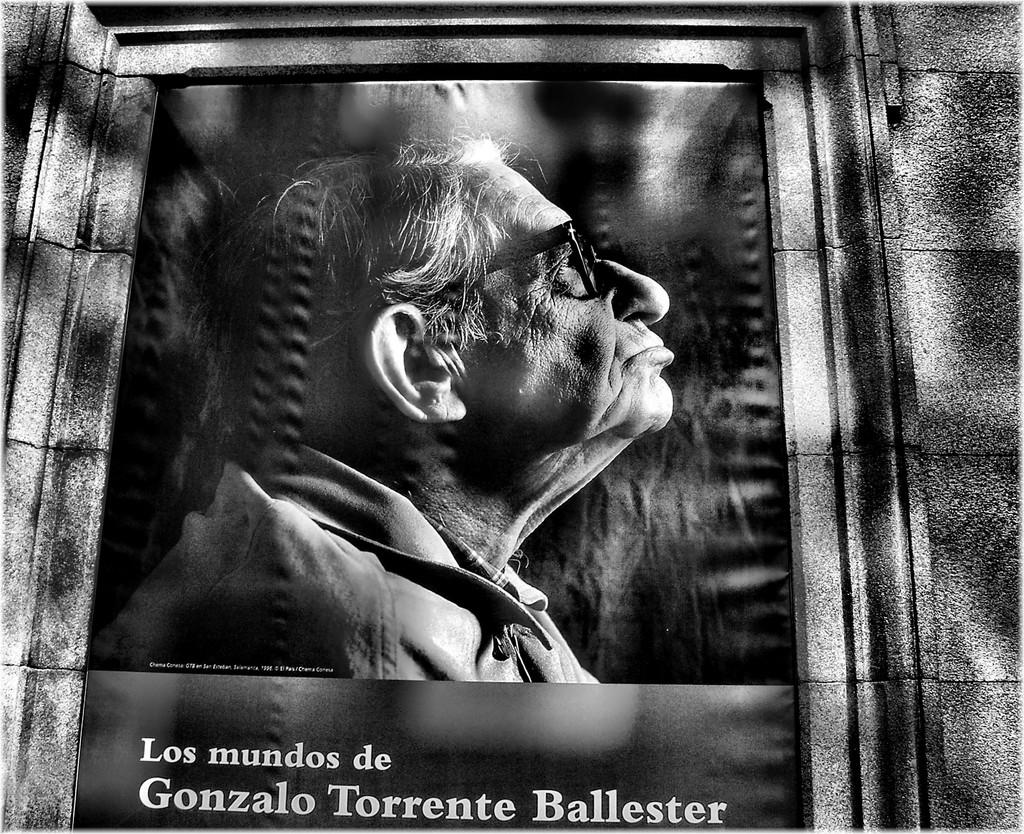What is present on the wall in the image? There is a poster in the image. How is the poster attached to the wall? The poster is attached to the wall. What is depicted in the picture on the poster? The picture on the poster contains a person wearing spectacles. What can be found below the picture on the poster? There is text below the picture on the poster. What word does the person on the poster feel ashamed about? There is no indication in the image that the person on the poster feels any shame, nor is there any specific word mentioned. 